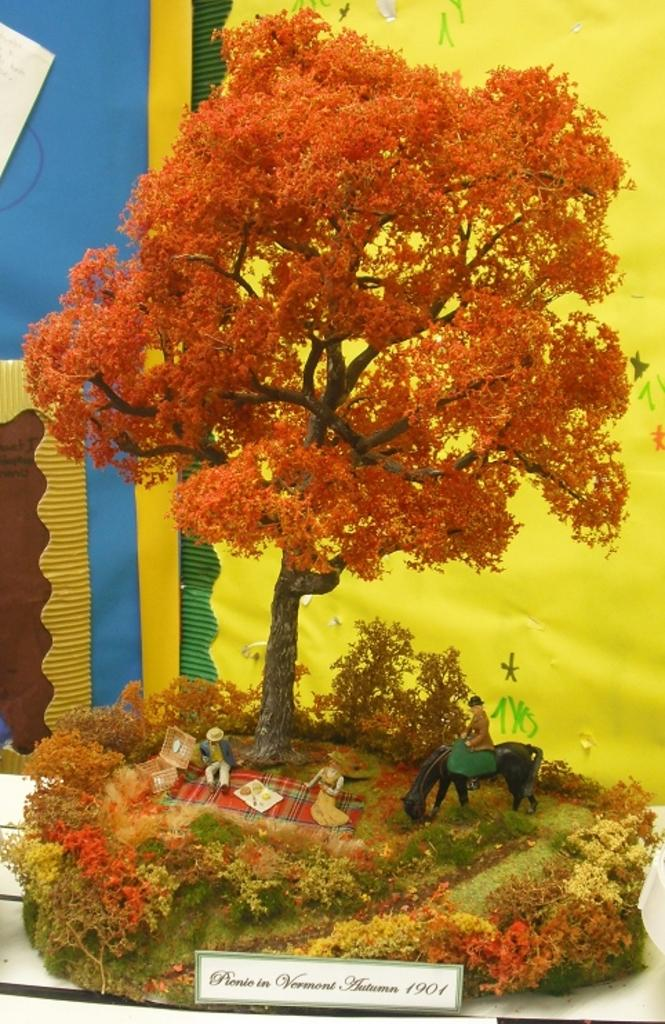What type of plant is featured in the image? There is a miniature tree in the image. What other types of plants can be seen in the image? There are plants in the image. Can you describe the people in the image? There are people in the image. What kind of animal is present in the image? There is an animal in the image. What else can be seen in the image besides plants and people? There are objects in the image. Is there any text visible in the image? Yes, there is a name board at the bottom of the image. What can be seen in the background of the image? There are objects visible in the background of the image. How many boys are sitting on the rabbit in the image? There are no boys or rabbits present in the image. What type of book is the animal reading in the image? There is no book or animal reading in the image. 